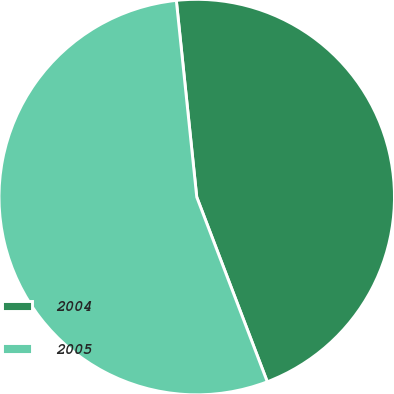Convert chart. <chart><loc_0><loc_0><loc_500><loc_500><pie_chart><fcel>2004<fcel>2005<nl><fcel>45.84%<fcel>54.16%<nl></chart> 